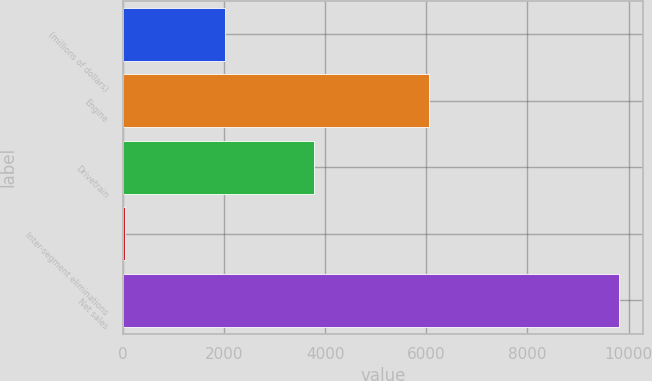<chart> <loc_0><loc_0><loc_500><loc_500><bar_chart><fcel>(millions of dollars)<fcel>Engine<fcel>Drivetrain<fcel>Inter-segment eliminations<fcel>Net sales<nl><fcel>2017<fcel>6061.5<fcel>3790.3<fcel>52.5<fcel>9799.3<nl></chart> 